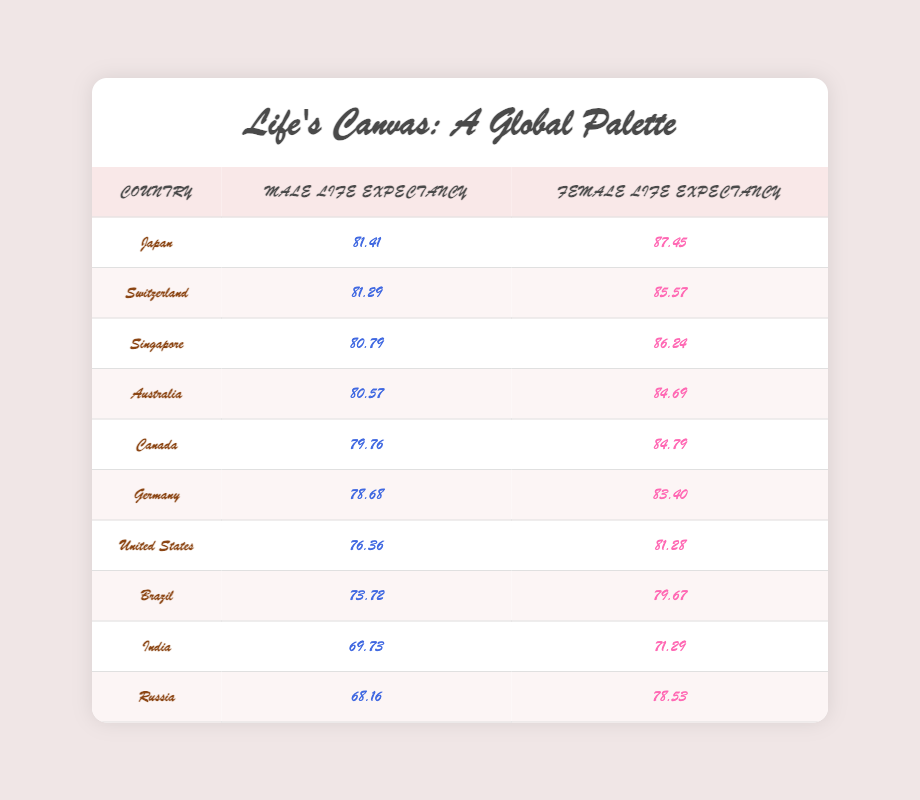What is the life expectancy for men in Japan? The table lists the values for life expectancy by country and gender. For Japan, the male life expectancy is provided directly in the table.
Answer: 81.41 Which country has the highest life expectancy for females? To determine this, we look across the female life expectancy column for all countries. Japan has the highest value at 87.45, which is greater than all other countries listed.
Answer: Japan What is the difference in life expectancy between males and females in Germany? For Germany, we find the male life expectancy (78.68) and the female life expectancy (83.40). The difference is calculated by subtracting the male value from the female value: 83.40 - 78.68 = 4.72.
Answer: 4.72 Is the life expectancy for males in the United States higher than that in Brazil? Looking at the table, the male life expectancy for the United States is 76.36, while for Brazil it is 73.72. Since 76.36 is greater, the statement is true.
Answer: Yes What is the average female life expectancy for the countries listed? To find the average, we first sum the female life expectancy values: 87.45 (Japan) + 85.57 (Switzerland) + 86.24 (Singapore) + 84.69 (Australia) + 84.79 (Canada) + 83.40 (Germany) + 81.28 (United States) + 79.67 (Brazil) + 71.29 (India) + 78.53 (Russia) = 840.15. Then, we divide the total by the number of countries (10): 840.15 / 10 = 84.015.
Answer: 84.015 Which countries have a higher female life expectancy than female life expectancy in India? The female life expectancy in India is 71.29. By reviewing the table, we can see that the countries with higher female life expectancy (greater than 71.29) are Japan, Switzerland, Singapore, Australia, Canada, Germany, the United States, Brazil, and Russia. Counting these, we find eight countries.
Answer: Eight countries What is the least life expectancy for males in this table? By assessing the male life expectancy values in the table, the lowest figure is found in Russia, at 68.16.
Answer: 68.16 In which country is the discrepancy between male and female life expectancy the largest? To find the largest discrepancy, we calculate the difference for each country: Japan (6.04), Switzerland (4.28), Singapore (5.45), Australia (4.12), Canada (5.03), Germany (4.72), United States (4.92), Brazil (5.95), India (1.56), and Russia (10.37). The largest discrepancy is 10.37 in Russia (female 78.53 - male 68.16).
Answer: Russia Do males in Canada live longer than females in India? From the table, Canada’s male life expectancy is 79.76 and India’s female life expectancy is 71.29. Since 79.76 is greater than 71.29, the statement is true.
Answer: Yes 